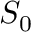<formula> <loc_0><loc_0><loc_500><loc_500>S _ { 0 }</formula> 